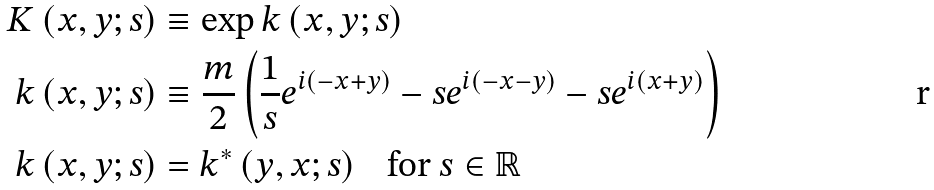<formula> <loc_0><loc_0><loc_500><loc_500>K \left ( x , y ; s \right ) & \equiv \exp k \left ( x , y ; s \right ) \\ k \left ( x , y ; s \right ) & \equiv \frac { m } { 2 } \left ( \frac { 1 } { s } e ^ { i \left ( - x + y \right ) } - s e ^ { i \left ( - x - y \right ) } - s e ^ { i \left ( x + y \right ) } \right ) \\ k \left ( x , y ; s \right ) & = k ^ { \ast } \left ( y , x ; s \right ) \text { \ \ for\ } s \in \mathbb { R }</formula> 